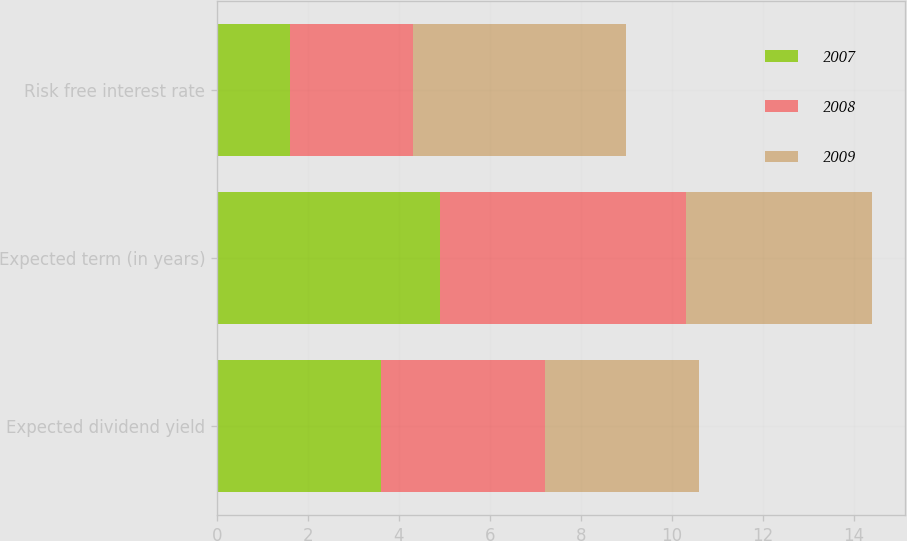Convert chart to OTSL. <chart><loc_0><loc_0><loc_500><loc_500><stacked_bar_chart><ecel><fcel>Expected dividend yield<fcel>Expected term (in years)<fcel>Risk free interest rate<nl><fcel>2007<fcel>3.6<fcel>4.9<fcel>1.6<nl><fcel>2008<fcel>3.6<fcel>5.4<fcel>2.7<nl><fcel>2009<fcel>3.4<fcel>4.1<fcel>4.7<nl></chart> 